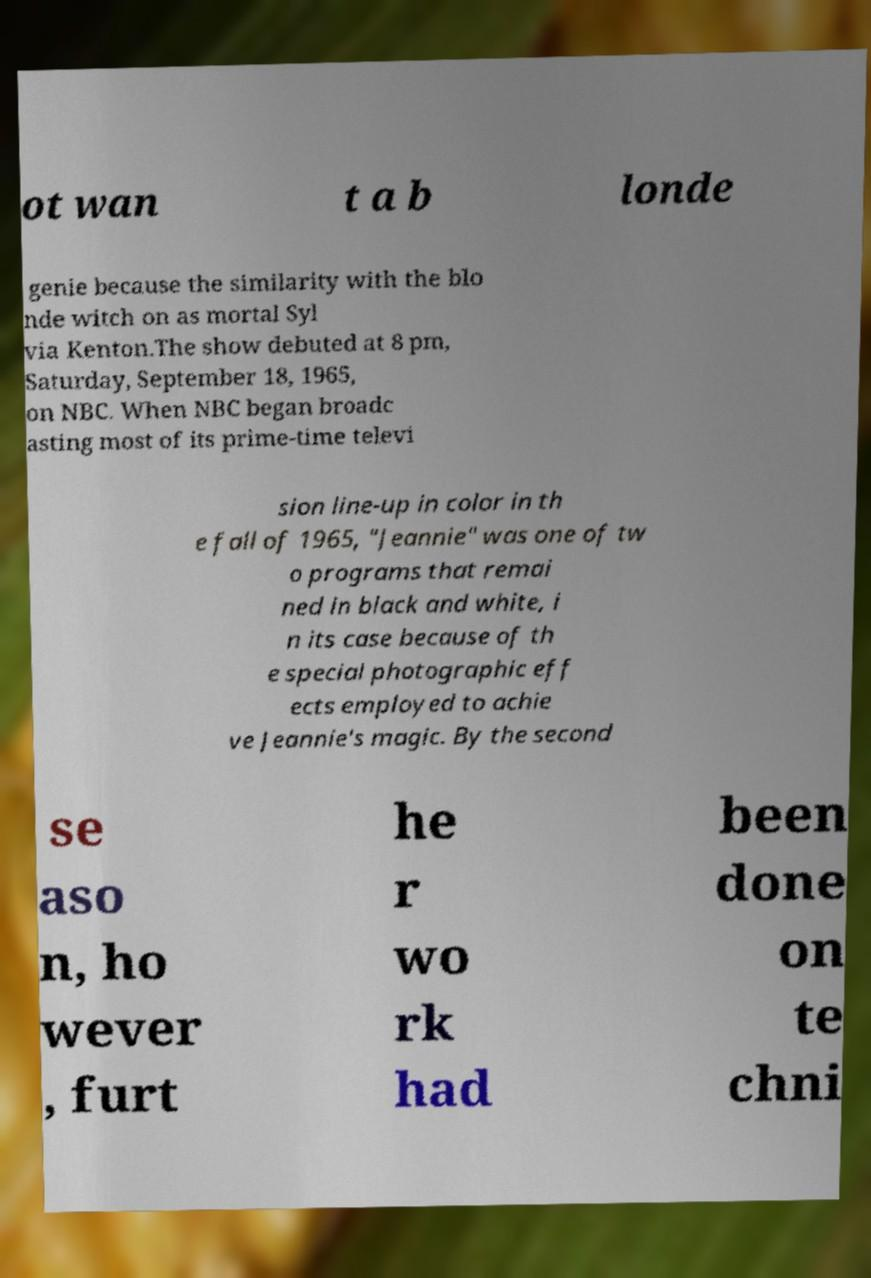Can you accurately transcribe the text from the provided image for me? ot wan t a b londe genie because the similarity with the blo nde witch on as mortal Syl via Kenton.The show debuted at 8 pm, Saturday, September 18, 1965, on NBC. When NBC began broadc asting most of its prime-time televi sion line-up in color in th e fall of 1965, "Jeannie" was one of tw o programs that remai ned in black and white, i n its case because of th e special photographic eff ects employed to achie ve Jeannie's magic. By the second se aso n, ho wever , furt he r wo rk had been done on te chni 